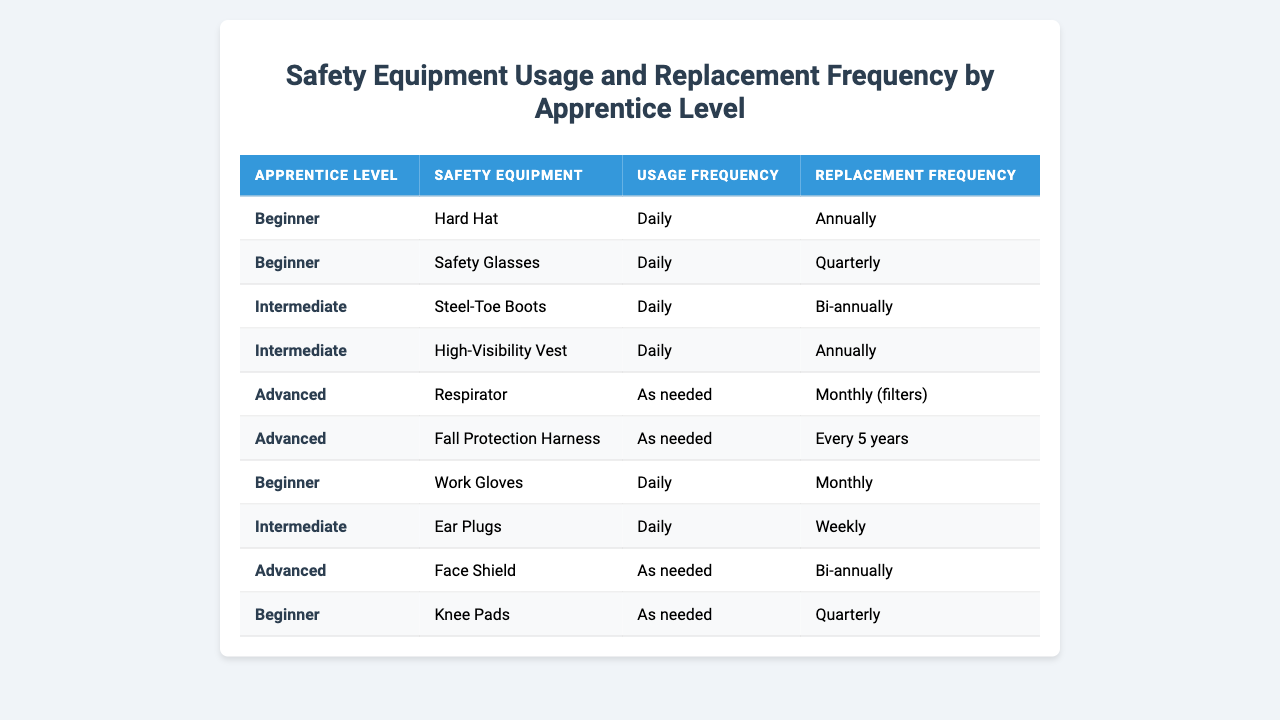What is the replacement frequency for Safety Glasses used by Beginners? The table shows that for Beginners, Safety Glasses have a replacement frequency listed as Quarterly.
Answer: Quarterly How often do Intermediate apprentices use Ear Plugs? According to the table, Intermediate apprentices use Ear Plugs Daily.
Answer: Daily Do Advanced apprentices need to replace their Fall Protection Harness monthly? The table indicates that Advanced apprentices replace their Fall Protection Harness every 5 years, not monthly.
Answer: No What is the usage frequency for Hard Hats among Beginners? The table specifies that Beginners use Hard Hats Daily.
Answer: Daily Which safety equipment has the highest replacement frequency for Beginners? Among the options in the table, Safety Glasses have the highest replacement frequency of Quarterly, while Work Gloves are replaced Monthly, and Hard Hats are replaced Annually.
Answer: Safety Glasses How many pieces of safety equipment do Intermediate apprentices use? From the table, there are two pieces of safety equipment for Intermediate apprentices: Steel-Toe Boots and High-Visibility Vest.
Answer: 2 Do Beginners need to use Knee Pads on a daily basis? The table states that Beginners use Knee Pads as needed, not daily.
Answer: No What is the average replacement frequency for safety equipment used by Advanced apprentices? The replacement frequencies for Advanced apprentices are: Monthly (for filters of the Respirator), Every 5 years (for Fall Protection Harness), and Bi-annually (for Face Shield). To find the average, we convert these into a comparable range, considering the intervals: Monthly as 1, Every 5 years as 60, Bi-annually as 6. The average is (1 + 60 + 6) / 3 = 22.33 months, or roughly every 22 months.
Answer: Approximately every 22 months Which type of safety equipment requires the least frequent replacement among Beginners? The table indicates that Hard Hats are replaced Annually, which is less frequent than the Monthly replacement for Work Gloves or Quarterly for Safety Glasses and Knee Pads.
Answer: Hard Hat Is there a specific safety equipment item that Intermediate apprentices do not use daily? The table shows that all safety equipment listed for Intermediate apprentices (Steel-Toe Boots, High-Visibility Vest, and Ear Plugs) are used Daily, indicating there is none that they do not use daily.
Answer: No 